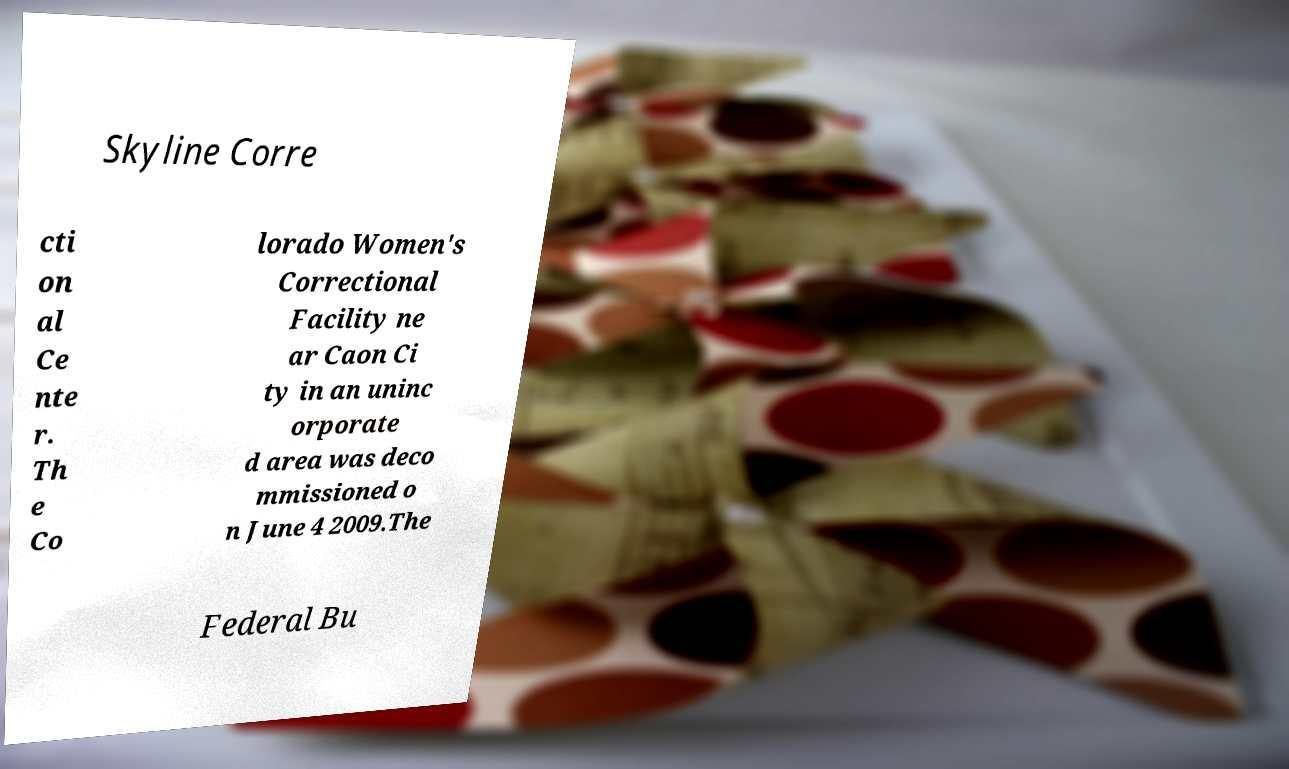Could you assist in decoding the text presented in this image and type it out clearly? Skyline Corre cti on al Ce nte r. Th e Co lorado Women's Correctional Facility ne ar Caon Ci ty in an uninc orporate d area was deco mmissioned o n June 4 2009.The Federal Bu 